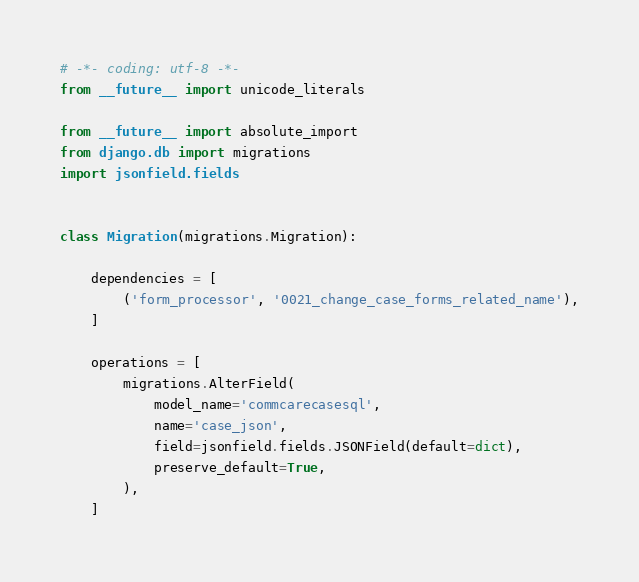<code> <loc_0><loc_0><loc_500><loc_500><_Python_># -*- coding: utf-8 -*-
from __future__ import unicode_literals

from __future__ import absolute_import
from django.db import migrations
import jsonfield.fields


class Migration(migrations.Migration):

    dependencies = [
        ('form_processor', '0021_change_case_forms_related_name'),
    ]

    operations = [
        migrations.AlterField(
            model_name='commcarecasesql',
            name='case_json',
            field=jsonfield.fields.JSONField(default=dict),
            preserve_default=True,
        ),
    ]
</code> 